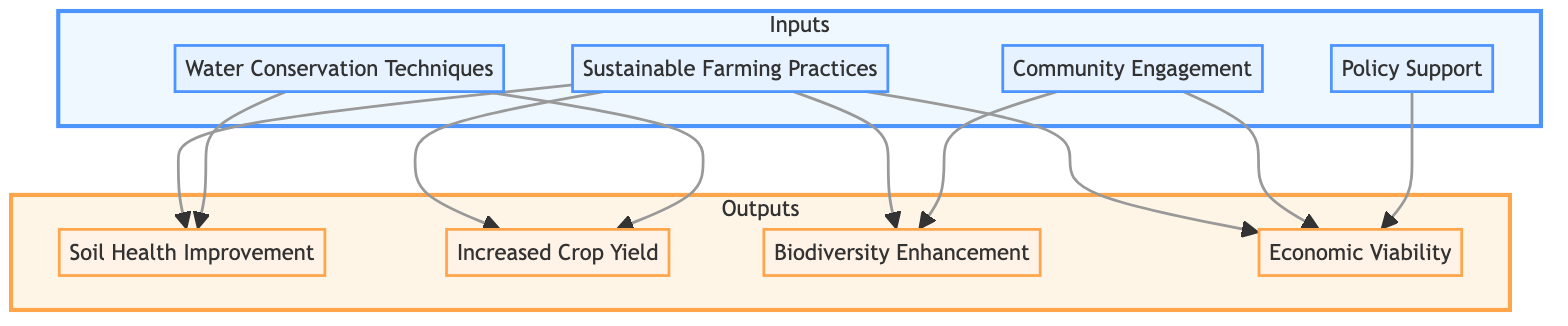What are the four input elements in the diagram? The diagram lists four input elements: Sustainable Farming Practices, Water Conservation Techniques, Community Engagement, and Policy Support.
Answer: Sustainable Farming Practices, Water Conservation Techniques, Community Engagement, Policy Support Which output elements are directly influenced by Sustainable Farming Practices? From the diagram, Sustainable Farming Practices influences all four output elements: Soil Health Improvement, Increased Crop Yield, Biodiversity Enhancement, and Economic Viability.
Answer: Soil Health Improvement, Increased Crop Yield, Biodiversity Enhancement, Economic Viability How many output elements are there in total? By counting the nodes in the output section of the diagram, there are four output elements listed: Soil Health Improvement, Increased Crop Yield, Biodiversity Enhancement, and Economic Viability.
Answer: 4 Which input contributes specifically to the Biodiversity Enhancement output? The input that contributes specifically to Biodiversity Enhancement is Community Engagement, as shown by the directed edge leading from Community Engagement to Biodiversity Enhancement.
Answer: Community Engagement What is the relationship between Policy Support and Economic Viability? The diagram indicates a direct influence; Policy Support is an input that leads to an increase in Economic Viability as shown by the directed edge from Policy Support to Economic Viability.
Answer: Direct influence Which input influences both Soil Health Improvement and Increased Crop Yield? The input that influences both Soil Health Improvement and Increased Crop Yield is Water Conservation Techniques, as shown by the directed edges leading from Water Conservation Techniques to both outputs.
Answer: Water Conservation Techniques How many total edges are there originating from the inputs? The total number of directed edges originating from the inputs is calculated as follows: Sustainable Farming Practices (4 edges), Water Conservation Techniques (2 edges), Community Engagement (2 edges), and Policy Support (1 edge), totaling to 9 edges.
Answer: 9 What is the main purpose of the Bottom Up Flow Chart? The main purpose of the Bottom Up Flow Chart is to illustrate how various sustainable farming practices as inputs lead to positive outputs in terms of soil health, crop yield, biodiversity, and economic viability.
Answer: To illustrate positive outputs from inputs in sustainable farming practices 